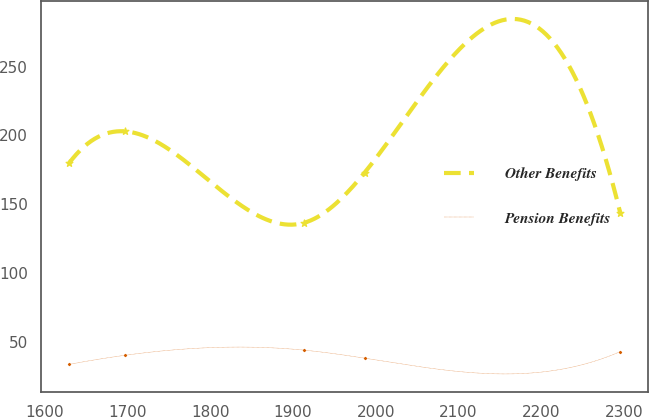Convert chart. <chart><loc_0><loc_0><loc_500><loc_500><line_chart><ecel><fcel>Other Benefits<fcel>Pension Benefits<nl><fcel>1629.19<fcel>179.73<fcel>33.89<nl><fcel>1696.73<fcel>202.96<fcel>40.5<nl><fcel>1913.29<fcel>136.6<fcel>44.25<nl><fcel>1986.57<fcel>173.09<fcel>38.4<nl><fcel>2295.27<fcel>143.94<fcel>43.14<nl></chart> 